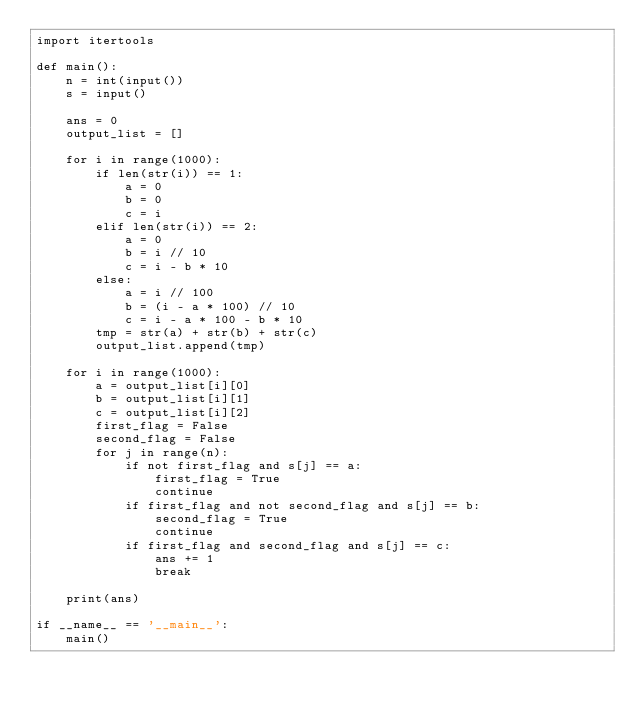Convert code to text. <code><loc_0><loc_0><loc_500><loc_500><_Python_>import itertools

def main():
    n = int(input())
    s = input()

    ans = 0
    output_list = []

    for i in range(1000):
        if len(str(i)) == 1:
            a = 0
            b = 0
            c = i
        elif len(str(i)) == 2:
            a = 0
            b = i // 10
            c = i - b * 10
        else:
            a = i // 100
            b = (i - a * 100) // 10
            c = i - a * 100 - b * 10
        tmp = str(a) + str(b) + str(c)
        output_list.append(tmp)
    
    for i in range(1000):
        a = output_list[i][0]
        b = output_list[i][1]
        c = output_list[i][2]
        first_flag = False
        second_flag = False
        for j in range(n):
            if not first_flag and s[j] == a:
                first_flag = True
                continue
            if first_flag and not second_flag and s[j] == b:
                second_flag = True
                continue
            if first_flag and second_flag and s[j] == c:
                ans += 1
                break

    print(ans)

if __name__ == '__main__':
    main()</code> 